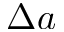Convert formula to latex. <formula><loc_0><loc_0><loc_500><loc_500>\Delta a</formula> 